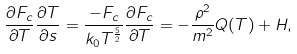<formula> <loc_0><loc_0><loc_500><loc_500>\frac { \partial F _ { c } } { \partial T } \frac { \partial T } { \partial s } = \frac { - F _ { c } } { k _ { 0 } T ^ { \frac { 5 } { 2 } } } \frac { \partial F _ { c } } { \partial T } = - \frac { \rho ^ { 2 } } { m ^ { 2 } } Q ( T ) + H ,</formula> 